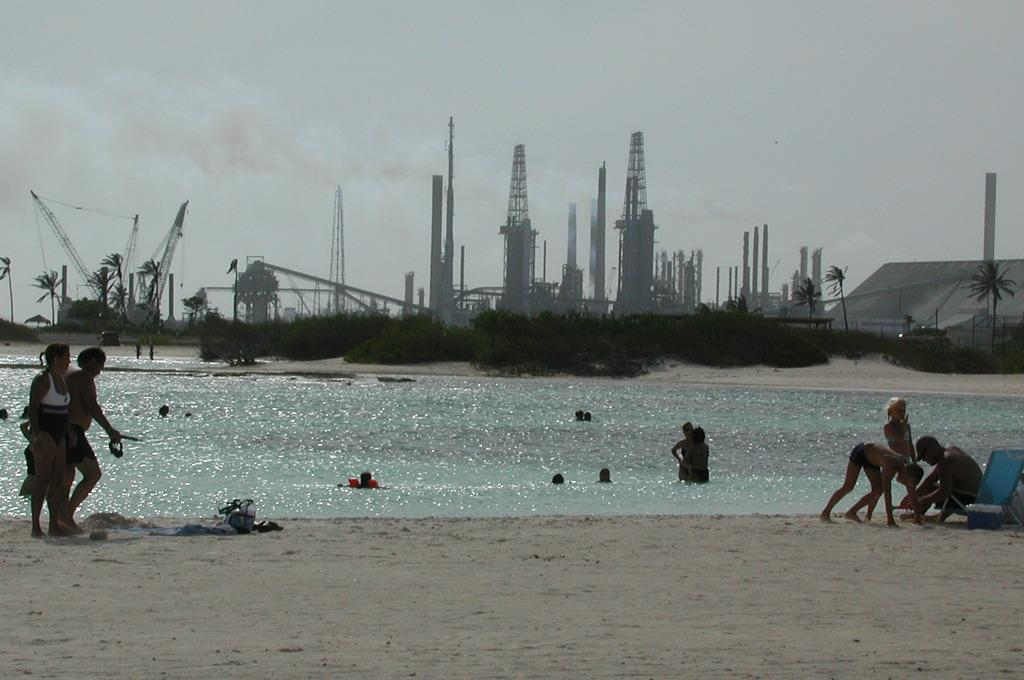What type of location is depicted in the image? There is a beach in the image. What are the people in the image doing? Two persons are walking on the beach, two persons are sitting and playing on the beach, and some people are swimming in the water. What can be seen in the background of the image? There is a group of trees visible in the image. What type of advertisement can be seen on the beach in the image? There is no advertisement present in the image; it depicts a beach scene with people and trees. Can you tell me where the bed is located in the image? There is no bed present in the image; it features a beach setting with people and trees. 